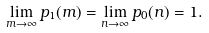<formula> <loc_0><loc_0><loc_500><loc_500>\lim _ { m \to \infty } p _ { 1 } ( m ) = \lim _ { n \to \infty } p _ { 0 } ( n ) = 1 .</formula> 